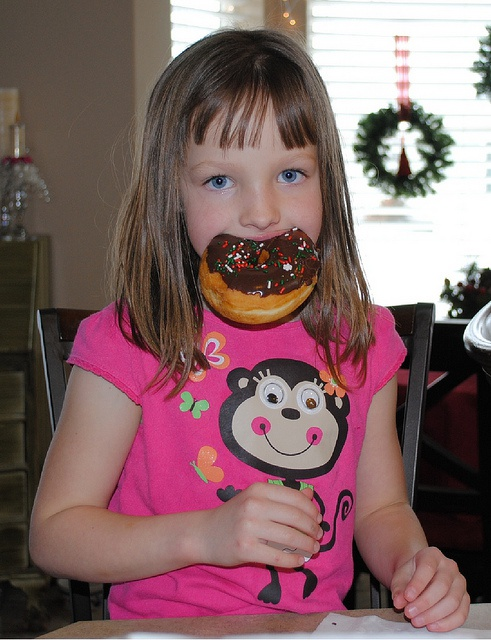Describe the objects in this image and their specific colors. I can see people in black, gray, and darkgray tones, chair in black, gray, and maroon tones, dining table in black, brown, darkgray, gray, and lightgray tones, donut in black, red, maroon, and tan tones, and bottle in black and gray tones in this image. 